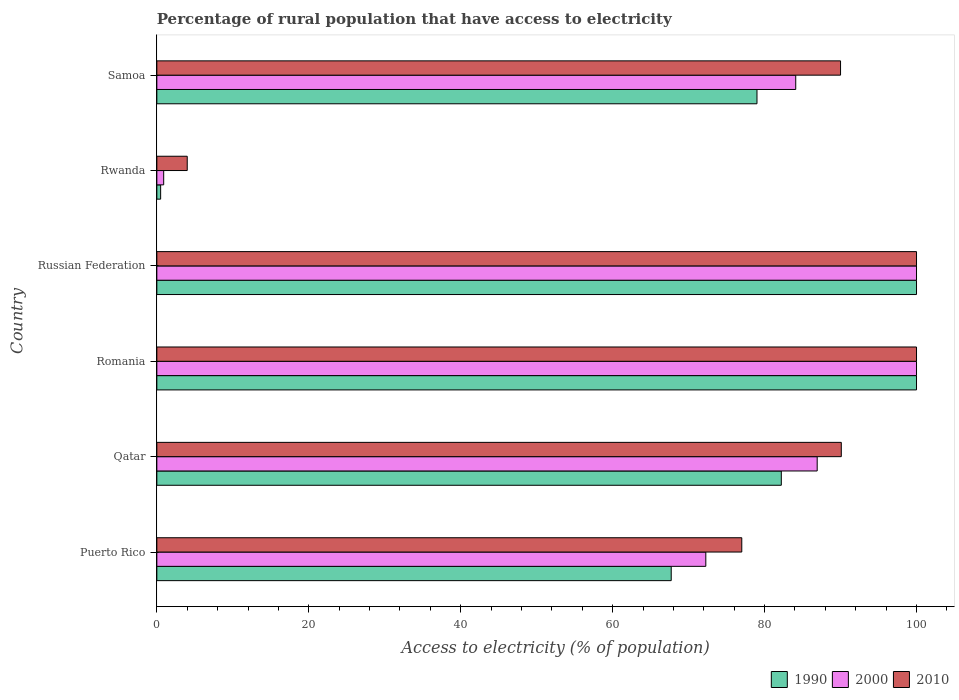Are the number of bars per tick equal to the number of legend labels?
Offer a very short reply. Yes. What is the label of the 4th group of bars from the top?
Offer a terse response. Romania. What is the percentage of rural population that have access to electricity in 1990 in Qatar?
Make the answer very short. 82.2. In which country was the percentage of rural population that have access to electricity in 2010 maximum?
Offer a terse response. Romania. In which country was the percentage of rural population that have access to electricity in 1990 minimum?
Your response must be concise. Rwanda. What is the total percentage of rural population that have access to electricity in 1990 in the graph?
Offer a terse response. 429.41. What is the difference between the percentage of rural population that have access to electricity in 1990 in Qatar and that in Rwanda?
Your answer should be compact. 81.7. What is the difference between the percentage of rural population that have access to electricity in 1990 in Russian Federation and the percentage of rural population that have access to electricity in 2010 in Romania?
Provide a short and direct response. 0. What is the average percentage of rural population that have access to electricity in 2010 per country?
Keep it short and to the point. 76.85. What is the difference between the percentage of rural population that have access to electricity in 2010 and percentage of rural population that have access to electricity in 2000 in Russian Federation?
Offer a terse response. 0. What is the ratio of the percentage of rural population that have access to electricity in 2010 in Qatar to that in Russian Federation?
Give a very brief answer. 0.9. What is the difference between the highest and the second highest percentage of rural population that have access to electricity in 2010?
Offer a very short reply. 0. What is the difference between the highest and the lowest percentage of rural population that have access to electricity in 2010?
Offer a very short reply. 96. In how many countries, is the percentage of rural population that have access to electricity in 2000 greater than the average percentage of rural population that have access to electricity in 2000 taken over all countries?
Offer a very short reply. 4. Is the sum of the percentage of rural population that have access to electricity in 1990 in Qatar and Rwanda greater than the maximum percentage of rural population that have access to electricity in 2000 across all countries?
Your answer should be very brief. No. What does the 3rd bar from the top in Rwanda represents?
Your answer should be very brief. 1990. Is it the case that in every country, the sum of the percentage of rural population that have access to electricity in 1990 and percentage of rural population that have access to electricity in 2000 is greater than the percentage of rural population that have access to electricity in 2010?
Ensure brevity in your answer.  No. Are all the bars in the graph horizontal?
Keep it short and to the point. Yes. How many countries are there in the graph?
Keep it short and to the point. 6. Are the values on the major ticks of X-axis written in scientific E-notation?
Keep it short and to the point. No. How many legend labels are there?
Provide a succinct answer. 3. How are the legend labels stacked?
Your response must be concise. Horizontal. What is the title of the graph?
Offer a very short reply. Percentage of rural population that have access to electricity. What is the label or title of the X-axis?
Your answer should be compact. Access to electricity (% of population). What is the label or title of the Y-axis?
Keep it short and to the point. Country. What is the Access to electricity (% of population) of 1990 in Puerto Rico?
Provide a short and direct response. 67.71. What is the Access to electricity (% of population) of 2000 in Puerto Rico?
Your answer should be very brief. 72.27. What is the Access to electricity (% of population) of 2010 in Puerto Rico?
Your answer should be compact. 77. What is the Access to electricity (% of population) in 1990 in Qatar?
Provide a short and direct response. 82.2. What is the Access to electricity (% of population) in 2000 in Qatar?
Keep it short and to the point. 86.93. What is the Access to electricity (% of population) in 2010 in Qatar?
Keep it short and to the point. 90.1. What is the Access to electricity (% of population) of 1990 in Romania?
Offer a terse response. 100. What is the Access to electricity (% of population) of 2000 in Romania?
Ensure brevity in your answer.  100. What is the Access to electricity (% of population) in 1990 in Russian Federation?
Your answer should be very brief. 100. What is the Access to electricity (% of population) of 2010 in Russian Federation?
Keep it short and to the point. 100. What is the Access to electricity (% of population) of 1990 in Rwanda?
Ensure brevity in your answer.  0.5. What is the Access to electricity (% of population) of 2000 in Rwanda?
Your response must be concise. 0.9. What is the Access to electricity (% of population) of 1990 in Samoa?
Your response must be concise. 79. What is the Access to electricity (% of population) in 2000 in Samoa?
Make the answer very short. 84.1. What is the Access to electricity (% of population) in 2010 in Samoa?
Provide a short and direct response. 90. Across all countries, what is the maximum Access to electricity (% of population) of 2000?
Keep it short and to the point. 100. Across all countries, what is the minimum Access to electricity (% of population) in 2000?
Your answer should be very brief. 0.9. Across all countries, what is the minimum Access to electricity (% of population) in 2010?
Give a very brief answer. 4. What is the total Access to electricity (% of population) of 1990 in the graph?
Your answer should be compact. 429.41. What is the total Access to electricity (% of population) in 2000 in the graph?
Give a very brief answer. 444.19. What is the total Access to electricity (% of population) of 2010 in the graph?
Your response must be concise. 461.1. What is the difference between the Access to electricity (% of population) in 1990 in Puerto Rico and that in Qatar?
Your response must be concise. -14.49. What is the difference between the Access to electricity (% of population) in 2000 in Puerto Rico and that in Qatar?
Your response must be concise. -14.66. What is the difference between the Access to electricity (% of population) of 1990 in Puerto Rico and that in Romania?
Your response must be concise. -32.29. What is the difference between the Access to electricity (% of population) of 2000 in Puerto Rico and that in Romania?
Keep it short and to the point. -27.73. What is the difference between the Access to electricity (% of population) in 1990 in Puerto Rico and that in Russian Federation?
Keep it short and to the point. -32.29. What is the difference between the Access to electricity (% of population) of 2000 in Puerto Rico and that in Russian Federation?
Make the answer very short. -27.73. What is the difference between the Access to electricity (% of population) in 2010 in Puerto Rico and that in Russian Federation?
Offer a very short reply. -23. What is the difference between the Access to electricity (% of population) in 1990 in Puerto Rico and that in Rwanda?
Your answer should be compact. 67.21. What is the difference between the Access to electricity (% of population) of 2000 in Puerto Rico and that in Rwanda?
Offer a terse response. 71.36. What is the difference between the Access to electricity (% of population) in 1990 in Puerto Rico and that in Samoa?
Keep it short and to the point. -11.29. What is the difference between the Access to electricity (% of population) of 2000 in Puerto Rico and that in Samoa?
Ensure brevity in your answer.  -11.84. What is the difference between the Access to electricity (% of population) of 1990 in Qatar and that in Romania?
Provide a short and direct response. -17.8. What is the difference between the Access to electricity (% of population) of 2000 in Qatar and that in Romania?
Your response must be concise. -13.07. What is the difference between the Access to electricity (% of population) in 2010 in Qatar and that in Romania?
Provide a succinct answer. -9.9. What is the difference between the Access to electricity (% of population) of 1990 in Qatar and that in Russian Federation?
Ensure brevity in your answer.  -17.8. What is the difference between the Access to electricity (% of population) of 2000 in Qatar and that in Russian Federation?
Make the answer very short. -13.07. What is the difference between the Access to electricity (% of population) of 1990 in Qatar and that in Rwanda?
Give a very brief answer. 81.7. What is the difference between the Access to electricity (% of population) in 2000 in Qatar and that in Rwanda?
Give a very brief answer. 86.03. What is the difference between the Access to electricity (% of population) in 2010 in Qatar and that in Rwanda?
Keep it short and to the point. 86.1. What is the difference between the Access to electricity (% of population) of 1990 in Qatar and that in Samoa?
Give a very brief answer. 3.2. What is the difference between the Access to electricity (% of population) in 2000 in Qatar and that in Samoa?
Offer a very short reply. 2.83. What is the difference between the Access to electricity (% of population) in 2010 in Qatar and that in Samoa?
Offer a very short reply. 0.1. What is the difference between the Access to electricity (% of population) in 2000 in Romania and that in Russian Federation?
Make the answer very short. 0. What is the difference between the Access to electricity (% of population) in 1990 in Romania and that in Rwanda?
Offer a terse response. 99.5. What is the difference between the Access to electricity (% of population) of 2000 in Romania and that in Rwanda?
Your response must be concise. 99.1. What is the difference between the Access to electricity (% of population) in 2010 in Romania and that in Rwanda?
Provide a succinct answer. 96. What is the difference between the Access to electricity (% of population) in 2000 in Romania and that in Samoa?
Offer a terse response. 15.9. What is the difference between the Access to electricity (% of population) of 2010 in Romania and that in Samoa?
Offer a very short reply. 10. What is the difference between the Access to electricity (% of population) of 1990 in Russian Federation and that in Rwanda?
Give a very brief answer. 99.5. What is the difference between the Access to electricity (% of population) in 2000 in Russian Federation and that in Rwanda?
Your answer should be compact. 99.1. What is the difference between the Access to electricity (% of population) in 2010 in Russian Federation and that in Rwanda?
Your response must be concise. 96. What is the difference between the Access to electricity (% of population) of 2000 in Russian Federation and that in Samoa?
Ensure brevity in your answer.  15.9. What is the difference between the Access to electricity (% of population) in 1990 in Rwanda and that in Samoa?
Ensure brevity in your answer.  -78.5. What is the difference between the Access to electricity (% of population) in 2000 in Rwanda and that in Samoa?
Your response must be concise. -83.2. What is the difference between the Access to electricity (% of population) of 2010 in Rwanda and that in Samoa?
Provide a short and direct response. -86. What is the difference between the Access to electricity (% of population) of 1990 in Puerto Rico and the Access to electricity (% of population) of 2000 in Qatar?
Provide a short and direct response. -19.21. What is the difference between the Access to electricity (% of population) in 1990 in Puerto Rico and the Access to electricity (% of population) in 2010 in Qatar?
Provide a succinct answer. -22.39. What is the difference between the Access to electricity (% of population) of 2000 in Puerto Rico and the Access to electricity (% of population) of 2010 in Qatar?
Ensure brevity in your answer.  -17.84. What is the difference between the Access to electricity (% of population) in 1990 in Puerto Rico and the Access to electricity (% of population) in 2000 in Romania?
Make the answer very short. -32.29. What is the difference between the Access to electricity (% of population) in 1990 in Puerto Rico and the Access to electricity (% of population) in 2010 in Romania?
Offer a very short reply. -32.29. What is the difference between the Access to electricity (% of population) of 2000 in Puerto Rico and the Access to electricity (% of population) of 2010 in Romania?
Your answer should be very brief. -27.73. What is the difference between the Access to electricity (% of population) in 1990 in Puerto Rico and the Access to electricity (% of population) in 2000 in Russian Federation?
Keep it short and to the point. -32.29. What is the difference between the Access to electricity (% of population) in 1990 in Puerto Rico and the Access to electricity (% of population) in 2010 in Russian Federation?
Offer a very short reply. -32.29. What is the difference between the Access to electricity (% of population) in 2000 in Puerto Rico and the Access to electricity (% of population) in 2010 in Russian Federation?
Ensure brevity in your answer.  -27.73. What is the difference between the Access to electricity (% of population) of 1990 in Puerto Rico and the Access to electricity (% of population) of 2000 in Rwanda?
Make the answer very short. 66.81. What is the difference between the Access to electricity (% of population) in 1990 in Puerto Rico and the Access to electricity (% of population) in 2010 in Rwanda?
Ensure brevity in your answer.  63.71. What is the difference between the Access to electricity (% of population) of 2000 in Puerto Rico and the Access to electricity (% of population) of 2010 in Rwanda?
Your answer should be very brief. 68.27. What is the difference between the Access to electricity (% of population) in 1990 in Puerto Rico and the Access to electricity (% of population) in 2000 in Samoa?
Provide a succinct answer. -16.39. What is the difference between the Access to electricity (% of population) in 1990 in Puerto Rico and the Access to electricity (% of population) in 2010 in Samoa?
Your answer should be very brief. -22.29. What is the difference between the Access to electricity (% of population) of 2000 in Puerto Rico and the Access to electricity (% of population) of 2010 in Samoa?
Your answer should be very brief. -17.73. What is the difference between the Access to electricity (% of population) of 1990 in Qatar and the Access to electricity (% of population) of 2000 in Romania?
Your answer should be compact. -17.8. What is the difference between the Access to electricity (% of population) of 1990 in Qatar and the Access to electricity (% of population) of 2010 in Romania?
Your response must be concise. -17.8. What is the difference between the Access to electricity (% of population) in 2000 in Qatar and the Access to electricity (% of population) in 2010 in Romania?
Your answer should be compact. -13.07. What is the difference between the Access to electricity (% of population) of 1990 in Qatar and the Access to electricity (% of population) of 2000 in Russian Federation?
Ensure brevity in your answer.  -17.8. What is the difference between the Access to electricity (% of population) of 1990 in Qatar and the Access to electricity (% of population) of 2010 in Russian Federation?
Provide a succinct answer. -17.8. What is the difference between the Access to electricity (% of population) of 2000 in Qatar and the Access to electricity (% of population) of 2010 in Russian Federation?
Offer a terse response. -13.07. What is the difference between the Access to electricity (% of population) in 1990 in Qatar and the Access to electricity (% of population) in 2000 in Rwanda?
Give a very brief answer. 81.3. What is the difference between the Access to electricity (% of population) in 1990 in Qatar and the Access to electricity (% of population) in 2010 in Rwanda?
Provide a short and direct response. 78.2. What is the difference between the Access to electricity (% of population) of 2000 in Qatar and the Access to electricity (% of population) of 2010 in Rwanda?
Your answer should be compact. 82.93. What is the difference between the Access to electricity (% of population) in 1990 in Qatar and the Access to electricity (% of population) in 2000 in Samoa?
Make the answer very short. -1.9. What is the difference between the Access to electricity (% of population) of 1990 in Qatar and the Access to electricity (% of population) of 2010 in Samoa?
Offer a very short reply. -7.8. What is the difference between the Access to electricity (% of population) of 2000 in Qatar and the Access to electricity (% of population) of 2010 in Samoa?
Provide a succinct answer. -3.07. What is the difference between the Access to electricity (% of population) in 1990 in Romania and the Access to electricity (% of population) in 2010 in Russian Federation?
Provide a short and direct response. 0. What is the difference between the Access to electricity (% of population) of 2000 in Romania and the Access to electricity (% of population) of 2010 in Russian Federation?
Provide a succinct answer. 0. What is the difference between the Access to electricity (% of population) in 1990 in Romania and the Access to electricity (% of population) in 2000 in Rwanda?
Provide a succinct answer. 99.1. What is the difference between the Access to electricity (% of population) in 1990 in Romania and the Access to electricity (% of population) in 2010 in Rwanda?
Your response must be concise. 96. What is the difference between the Access to electricity (% of population) in 2000 in Romania and the Access to electricity (% of population) in 2010 in Rwanda?
Provide a succinct answer. 96. What is the difference between the Access to electricity (% of population) in 1990 in Romania and the Access to electricity (% of population) in 2000 in Samoa?
Ensure brevity in your answer.  15.9. What is the difference between the Access to electricity (% of population) of 1990 in Romania and the Access to electricity (% of population) of 2010 in Samoa?
Ensure brevity in your answer.  10. What is the difference between the Access to electricity (% of population) of 2000 in Romania and the Access to electricity (% of population) of 2010 in Samoa?
Your response must be concise. 10. What is the difference between the Access to electricity (% of population) of 1990 in Russian Federation and the Access to electricity (% of population) of 2000 in Rwanda?
Your answer should be very brief. 99.1. What is the difference between the Access to electricity (% of population) in 1990 in Russian Federation and the Access to electricity (% of population) in 2010 in Rwanda?
Provide a succinct answer. 96. What is the difference between the Access to electricity (% of population) in 2000 in Russian Federation and the Access to electricity (% of population) in 2010 in Rwanda?
Give a very brief answer. 96. What is the difference between the Access to electricity (% of population) in 1990 in Russian Federation and the Access to electricity (% of population) in 2000 in Samoa?
Your answer should be very brief. 15.9. What is the difference between the Access to electricity (% of population) in 2000 in Russian Federation and the Access to electricity (% of population) in 2010 in Samoa?
Provide a short and direct response. 10. What is the difference between the Access to electricity (% of population) of 1990 in Rwanda and the Access to electricity (% of population) of 2000 in Samoa?
Keep it short and to the point. -83.6. What is the difference between the Access to electricity (% of population) in 1990 in Rwanda and the Access to electricity (% of population) in 2010 in Samoa?
Make the answer very short. -89.5. What is the difference between the Access to electricity (% of population) of 2000 in Rwanda and the Access to electricity (% of population) of 2010 in Samoa?
Make the answer very short. -89.1. What is the average Access to electricity (% of population) of 1990 per country?
Your answer should be very brief. 71.57. What is the average Access to electricity (% of population) in 2000 per country?
Your response must be concise. 74.03. What is the average Access to electricity (% of population) in 2010 per country?
Your answer should be compact. 76.85. What is the difference between the Access to electricity (% of population) of 1990 and Access to electricity (% of population) of 2000 in Puerto Rico?
Your response must be concise. -4.55. What is the difference between the Access to electricity (% of population) of 1990 and Access to electricity (% of population) of 2010 in Puerto Rico?
Provide a succinct answer. -9.29. What is the difference between the Access to electricity (% of population) of 2000 and Access to electricity (% of population) of 2010 in Puerto Rico?
Provide a short and direct response. -4.74. What is the difference between the Access to electricity (% of population) in 1990 and Access to electricity (% of population) in 2000 in Qatar?
Make the answer very short. -4.72. What is the difference between the Access to electricity (% of population) in 1990 and Access to electricity (% of population) in 2010 in Qatar?
Offer a very short reply. -7.9. What is the difference between the Access to electricity (% of population) in 2000 and Access to electricity (% of population) in 2010 in Qatar?
Your response must be concise. -3.17. What is the difference between the Access to electricity (% of population) of 1990 and Access to electricity (% of population) of 2000 in Romania?
Your answer should be very brief. 0. What is the difference between the Access to electricity (% of population) in 1990 and Access to electricity (% of population) in 2000 in Russian Federation?
Your answer should be compact. 0. What is the difference between the Access to electricity (% of population) of 1990 and Access to electricity (% of population) of 2010 in Russian Federation?
Your answer should be very brief. 0. What is the difference between the Access to electricity (% of population) in 1990 and Access to electricity (% of population) in 2000 in Rwanda?
Give a very brief answer. -0.4. What is the difference between the Access to electricity (% of population) of 1990 and Access to electricity (% of population) of 2010 in Rwanda?
Give a very brief answer. -3.5. What is the difference between the Access to electricity (% of population) in 2000 and Access to electricity (% of population) in 2010 in Rwanda?
Keep it short and to the point. -3.1. What is the difference between the Access to electricity (% of population) of 1990 and Access to electricity (% of population) of 2000 in Samoa?
Your answer should be compact. -5.1. What is the difference between the Access to electricity (% of population) of 2000 and Access to electricity (% of population) of 2010 in Samoa?
Offer a terse response. -5.9. What is the ratio of the Access to electricity (% of population) of 1990 in Puerto Rico to that in Qatar?
Ensure brevity in your answer.  0.82. What is the ratio of the Access to electricity (% of population) in 2000 in Puerto Rico to that in Qatar?
Keep it short and to the point. 0.83. What is the ratio of the Access to electricity (% of population) of 2010 in Puerto Rico to that in Qatar?
Offer a very short reply. 0.85. What is the ratio of the Access to electricity (% of population) in 1990 in Puerto Rico to that in Romania?
Offer a very short reply. 0.68. What is the ratio of the Access to electricity (% of population) in 2000 in Puerto Rico to that in Romania?
Your answer should be very brief. 0.72. What is the ratio of the Access to electricity (% of population) of 2010 in Puerto Rico to that in Romania?
Keep it short and to the point. 0.77. What is the ratio of the Access to electricity (% of population) in 1990 in Puerto Rico to that in Russian Federation?
Offer a terse response. 0.68. What is the ratio of the Access to electricity (% of population) in 2000 in Puerto Rico to that in Russian Federation?
Ensure brevity in your answer.  0.72. What is the ratio of the Access to electricity (% of population) of 2010 in Puerto Rico to that in Russian Federation?
Provide a short and direct response. 0.77. What is the ratio of the Access to electricity (% of population) of 1990 in Puerto Rico to that in Rwanda?
Provide a short and direct response. 135.42. What is the ratio of the Access to electricity (% of population) of 2000 in Puerto Rico to that in Rwanda?
Keep it short and to the point. 80.29. What is the ratio of the Access to electricity (% of population) of 2010 in Puerto Rico to that in Rwanda?
Offer a terse response. 19.25. What is the ratio of the Access to electricity (% of population) of 2000 in Puerto Rico to that in Samoa?
Keep it short and to the point. 0.86. What is the ratio of the Access to electricity (% of population) in 2010 in Puerto Rico to that in Samoa?
Your answer should be compact. 0.86. What is the ratio of the Access to electricity (% of population) of 1990 in Qatar to that in Romania?
Your answer should be very brief. 0.82. What is the ratio of the Access to electricity (% of population) of 2000 in Qatar to that in Romania?
Provide a short and direct response. 0.87. What is the ratio of the Access to electricity (% of population) in 2010 in Qatar to that in Romania?
Offer a terse response. 0.9. What is the ratio of the Access to electricity (% of population) of 1990 in Qatar to that in Russian Federation?
Give a very brief answer. 0.82. What is the ratio of the Access to electricity (% of population) of 2000 in Qatar to that in Russian Federation?
Give a very brief answer. 0.87. What is the ratio of the Access to electricity (% of population) of 2010 in Qatar to that in Russian Federation?
Offer a very short reply. 0.9. What is the ratio of the Access to electricity (% of population) of 1990 in Qatar to that in Rwanda?
Your answer should be compact. 164.41. What is the ratio of the Access to electricity (% of population) of 2000 in Qatar to that in Rwanda?
Offer a terse response. 96.58. What is the ratio of the Access to electricity (% of population) of 2010 in Qatar to that in Rwanda?
Offer a terse response. 22.52. What is the ratio of the Access to electricity (% of population) of 1990 in Qatar to that in Samoa?
Offer a terse response. 1.04. What is the ratio of the Access to electricity (% of population) of 2000 in Qatar to that in Samoa?
Give a very brief answer. 1.03. What is the ratio of the Access to electricity (% of population) in 1990 in Romania to that in Russian Federation?
Make the answer very short. 1. What is the ratio of the Access to electricity (% of population) in 1990 in Romania to that in Rwanda?
Your response must be concise. 200. What is the ratio of the Access to electricity (% of population) in 2000 in Romania to that in Rwanda?
Offer a very short reply. 111.11. What is the ratio of the Access to electricity (% of population) of 1990 in Romania to that in Samoa?
Your answer should be compact. 1.27. What is the ratio of the Access to electricity (% of population) in 2000 in Romania to that in Samoa?
Provide a succinct answer. 1.19. What is the ratio of the Access to electricity (% of population) of 1990 in Russian Federation to that in Rwanda?
Keep it short and to the point. 200. What is the ratio of the Access to electricity (% of population) in 2000 in Russian Federation to that in Rwanda?
Keep it short and to the point. 111.11. What is the ratio of the Access to electricity (% of population) of 2010 in Russian Federation to that in Rwanda?
Your response must be concise. 25. What is the ratio of the Access to electricity (% of population) in 1990 in Russian Federation to that in Samoa?
Your answer should be very brief. 1.27. What is the ratio of the Access to electricity (% of population) of 2000 in Russian Federation to that in Samoa?
Ensure brevity in your answer.  1.19. What is the ratio of the Access to electricity (% of population) in 1990 in Rwanda to that in Samoa?
Offer a very short reply. 0.01. What is the ratio of the Access to electricity (% of population) in 2000 in Rwanda to that in Samoa?
Provide a succinct answer. 0.01. What is the ratio of the Access to electricity (% of population) of 2010 in Rwanda to that in Samoa?
Offer a terse response. 0.04. What is the difference between the highest and the second highest Access to electricity (% of population) in 1990?
Your response must be concise. 0. What is the difference between the highest and the second highest Access to electricity (% of population) in 2000?
Offer a very short reply. 0. What is the difference between the highest and the second highest Access to electricity (% of population) in 2010?
Give a very brief answer. 0. What is the difference between the highest and the lowest Access to electricity (% of population) of 1990?
Your response must be concise. 99.5. What is the difference between the highest and the lowest Access to electricity (% of population) in 2000?
Your answer should be very brief. 99.1. What is the difference between the highest and the lowest Access to electricity (% of population) in 2010?
Keep it short and to the point. 96. 